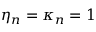Convert formula to latex. <formula><loc_0><loc_0><loc_500><loc_500>\eta _ { n } = \kappa _ { n } = 1</formula> 